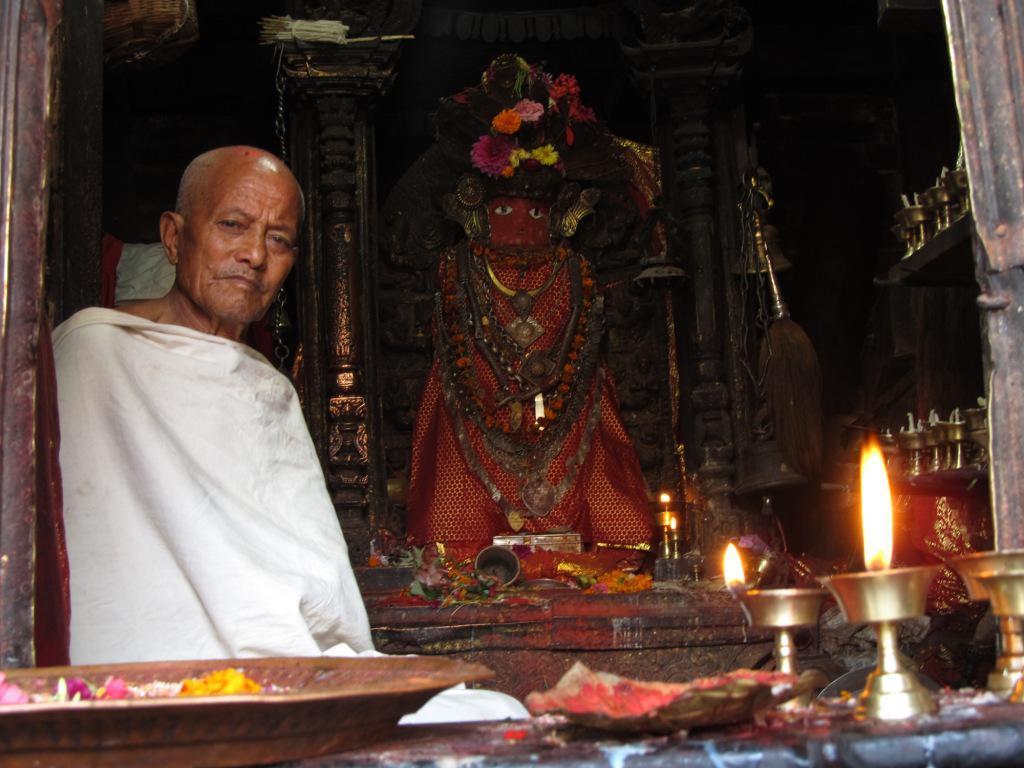Could you give a brief overview of what you see in this image? In this picture I can see a man sitting. There is a statue. I can see flowers, samai oil lamps and some other objects. 